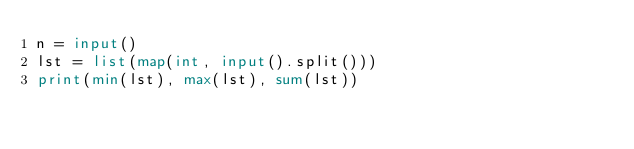<code> <loc_0><loc_0><loc_500><loc_500><_Python_>n = input()
lst = list(map(int, input().split()))
print(min(lst), max(lst), sum(lst))

</code> 